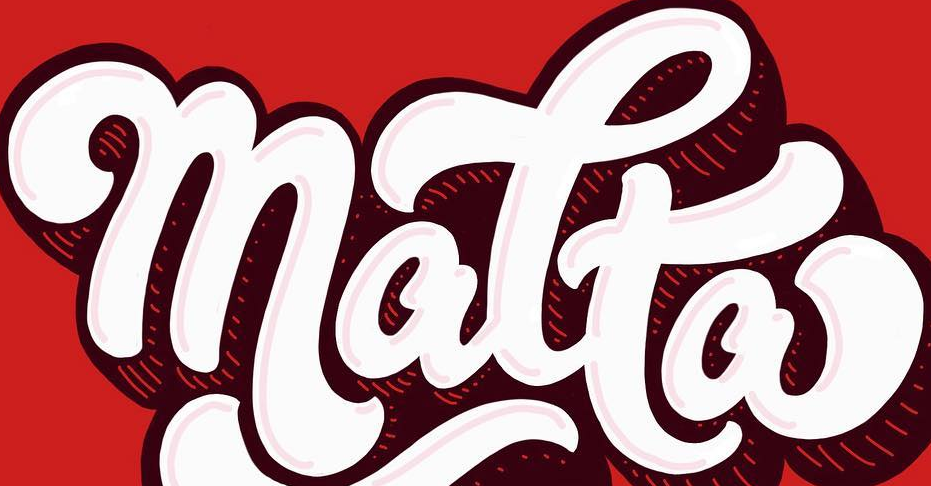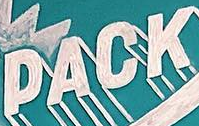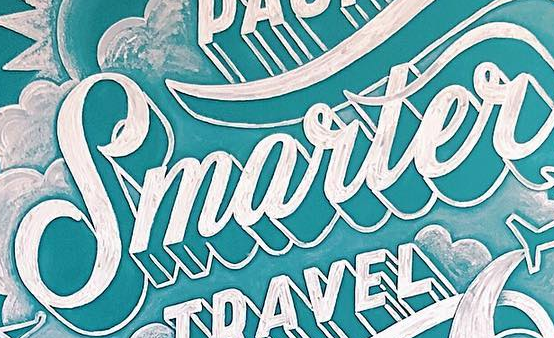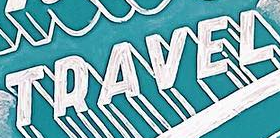Identify the words shown in these images in order, separated by a semicolon. matta; PACK; Smarter; TRAVEL 